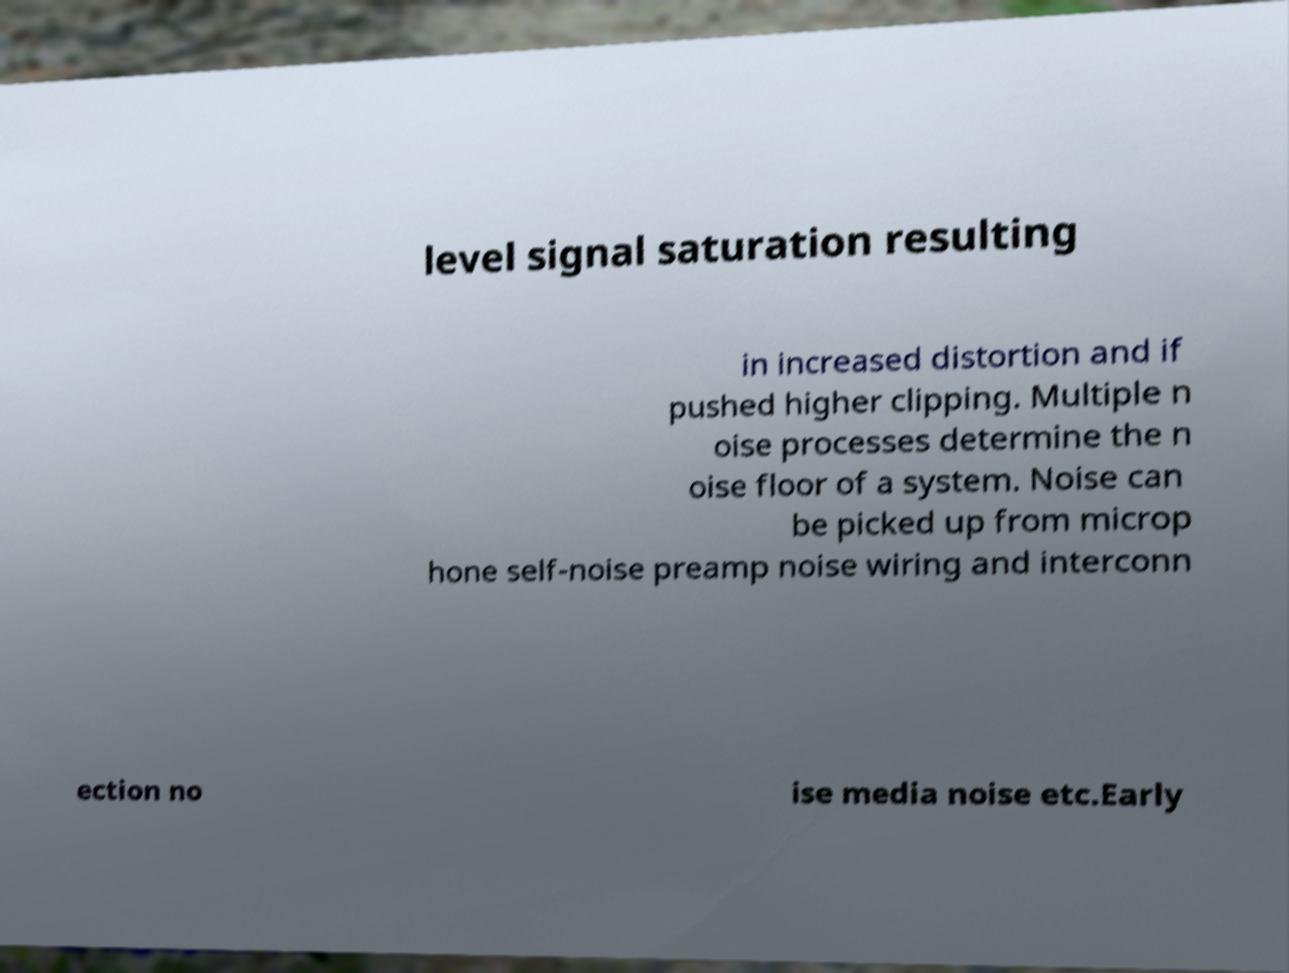Please read and relay the text visible in this image. What does it say? level signal saturation resulting in increased distortion and if pushed higher clipping. Multiple n oise processes determine the n oise floor of a system. Noise can be picked up from microp hone self-noise preamp noise wiring and interconn ection no ise media noise etc.Early 